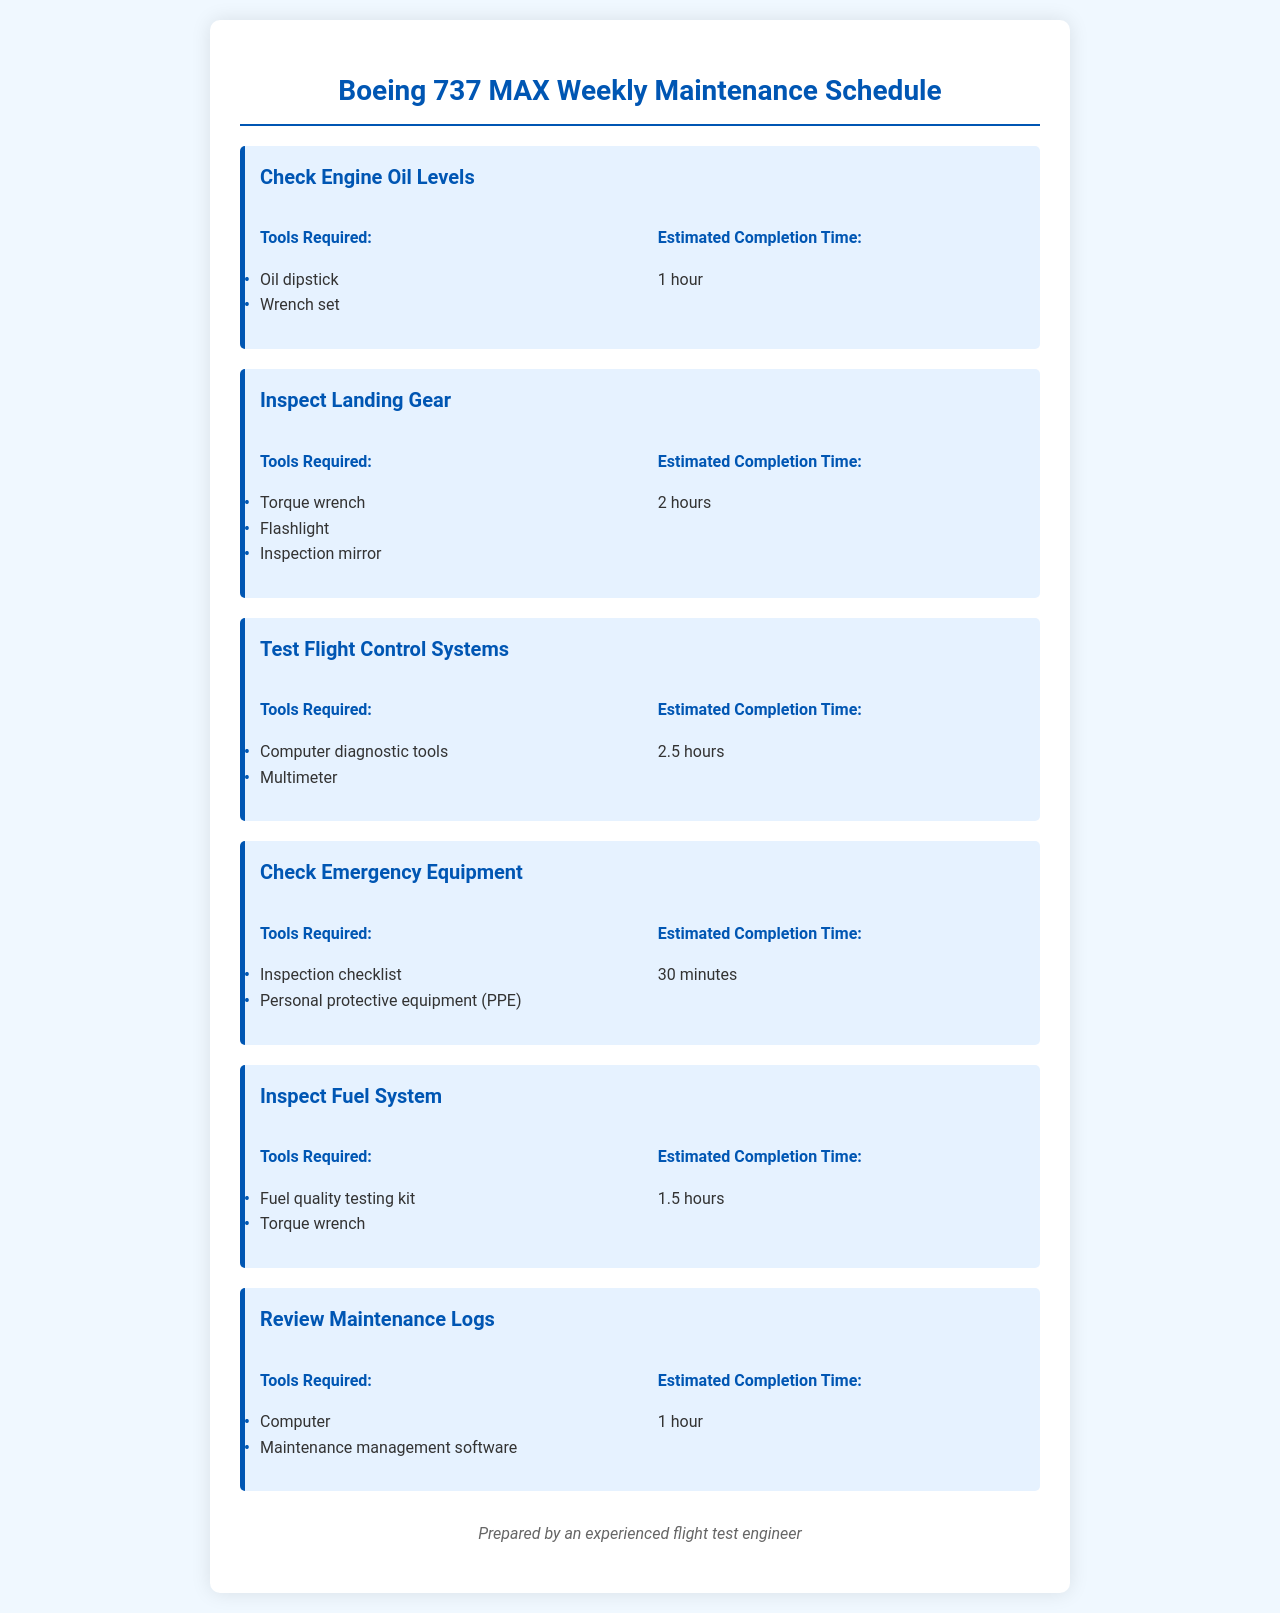What is the first task listed in the schedule? The first task is "Check Engine Oil Levels," as it appears at the top of the scheduled tasks.
Answer: Check Engine Oil Levels How long is the estimated time to inspect the landing gear? The estimated time for inspecting the landing gear, as specified in the document, is 2 hours.
Answer: 2 hours What tools are needed to check the emergency equipment? The document lists "Inspection checklist" and "Personal protective equipment (PPE)" as the tools required for checking the emergency equipment.
Answer: Inspection checklist, Personal protective equipment (PPE) How many hours are estimated for testing flight control systems? According to the schedule, testing flight control systems takes 2.5 hours, as mentioned under the related task.
Answer: 2.5 hours What is the estimated completion time for reviewing maintenance logs? The estimated completion time for reviewing maintenance logs is stated as 1 hour in the schedule.
Answer: 1 hour Which inspection task has the shortest completion time? The task that has the shortest completion time is "Check Emergency Equipment," which is scheduled for 30 minutes.
Answer: Check Emergency Equipment What are the tools required for inspecting the fuel system? The tools required for inspecting the fuel system, as indicated in the document, are "Fuel quality testing kit" and "Torque wrench."
Answer: Fuel quality testing kit, Torque wrench How many total tasks are listed in the schedule? The schedule includes a total of six tasks related to the maintenance and inspection of the aircraft.
Answer: 6 tasks 